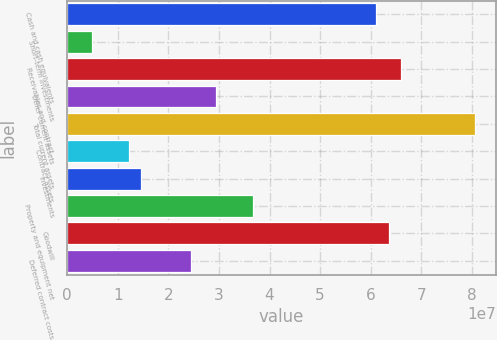Convert chart. <chart><loc_0><loc_0><loc_500><loc_500><bar_chart><fcel>Cash and cash equivalents<fcel>Short-term investments<fcel>Receivables and contract<fcel>Other current assets<fcel>Total current assets<fcel>Contract assets<fcel>Investments<fcel>Property and equipment net<fcel>Goodwill<fcel>Deferred contract costs<nl><fcel>6.11227e+07<fcel>4.88983e+06<fcel>6.60125e+07<fcel>2.93389e+07<fcel>8.06819e+07<fcel>1.22245e+07<fcel>1.46695e+07<fcel>3.66736e+07<fcel>6.35676e+07<fcel>2.44491e+07<nl></chart> 